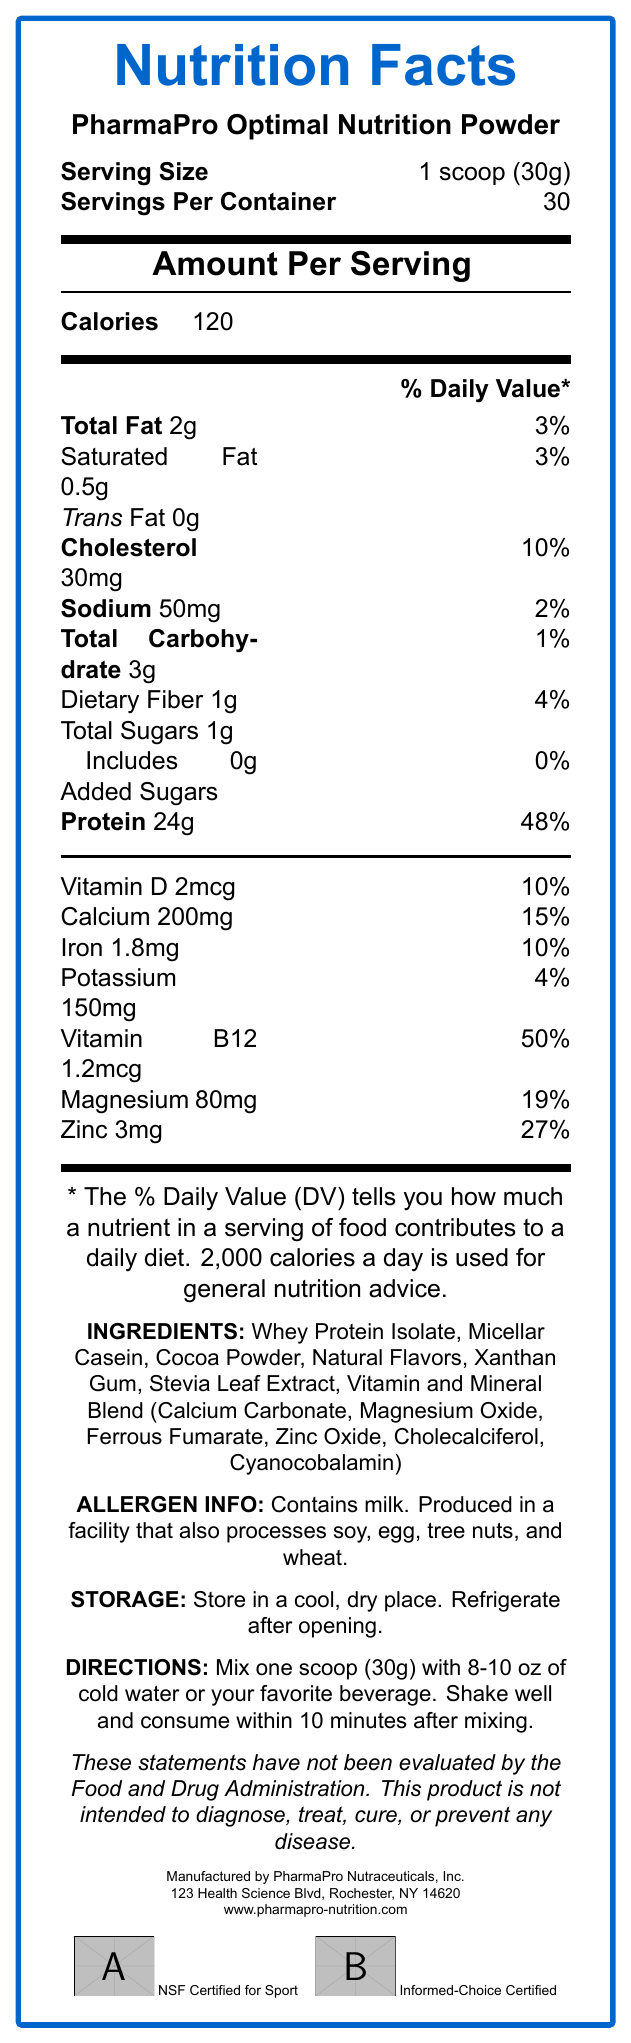what is the serving size? The serving size is clearly listed at the top of the Nutrition Facts Label.
Answer: 1 scoop (30g) how many servings are in one container? The document mentions that there are 30 servings per container.
Answer: 30 how many calories are in one serving? The amount per serving section of the label states that there are 120 calories per serving.
Answer: 120 how much protein is in one serving? The label shows that each serving contains 24 grams of protein.
Answer: 24g how much added sugar does the product have per serving? The label lists that there are 0 grams of added sugars.
Answer: 0g what is the % Daily Value of calcium in one serving? The nutrient section lists the % Daily Value of calcium as 15%.
Answer: 15% what is the total fat content per serving? A. 0g B. 2g C. 3g D. 5g The label shows that the total fat content per serving is 2 grams.
Answer: B which of the following vitamins and minerals has the highest % Daily Value per serving? I. Vitamin D II. Iron III. Vitamin B12 IV. Zinc Vitamin B12 has the highest % Daily Value per serving at 50%.
Answer: III does this product contain any allergens? The allergen info section mentions that the product contains milk.
Answer: Yes is this product intended to diagnose, treat, cure, or prevent any disease? The disclaimer clearly states that this product is not intended to diagnose, treat, cure, or prevent any disease.
Answer: No briefly summarize the main purpose of the document. The document gives a comprehensive overview of the nutritional content, usage, and important information regarding PharmaPro Optimal Nutrition Powder.
Answer: The document provides the Nutrition Facts for PharmaPro Optimal Nutrition Powder, including serving size, caloric content, fat, protein, carbohydrate details, and vitamin and mineral content per serving. It also includes directions for use, allergen information, storage instructions, and disclaimers. what is the daily value percentage of dietary fiber? The label indicates that the % Daily Value for dietary fiber is 4%.
Answer: 4% how many milligrams of magnesium are in one serving? The label shows that there are 80 milligrams of magnesium per serving.
Answer: 80mg can the exact shelf life of the product be determined from the document? The document provides storage instructions but does not specify the exact shelf life of the product.
Answer: Cannot be determined what company manufactures this product? The bottom of the document states that the product is manufactured by PharmaPro Nutraceuticals, Inc.
Answer: PharmaPro Nutraceuticals, Inc. how much cholesterol is in one serving? The label indicates that there are 30 milligrams of cholesterol per serving.
Answer: 30mg which website can you visit for more information about this product? The document mentions the website www.pharmapro-nutrition.com for more information about the product.
Answer: www.pharmapro-nutrition.com 